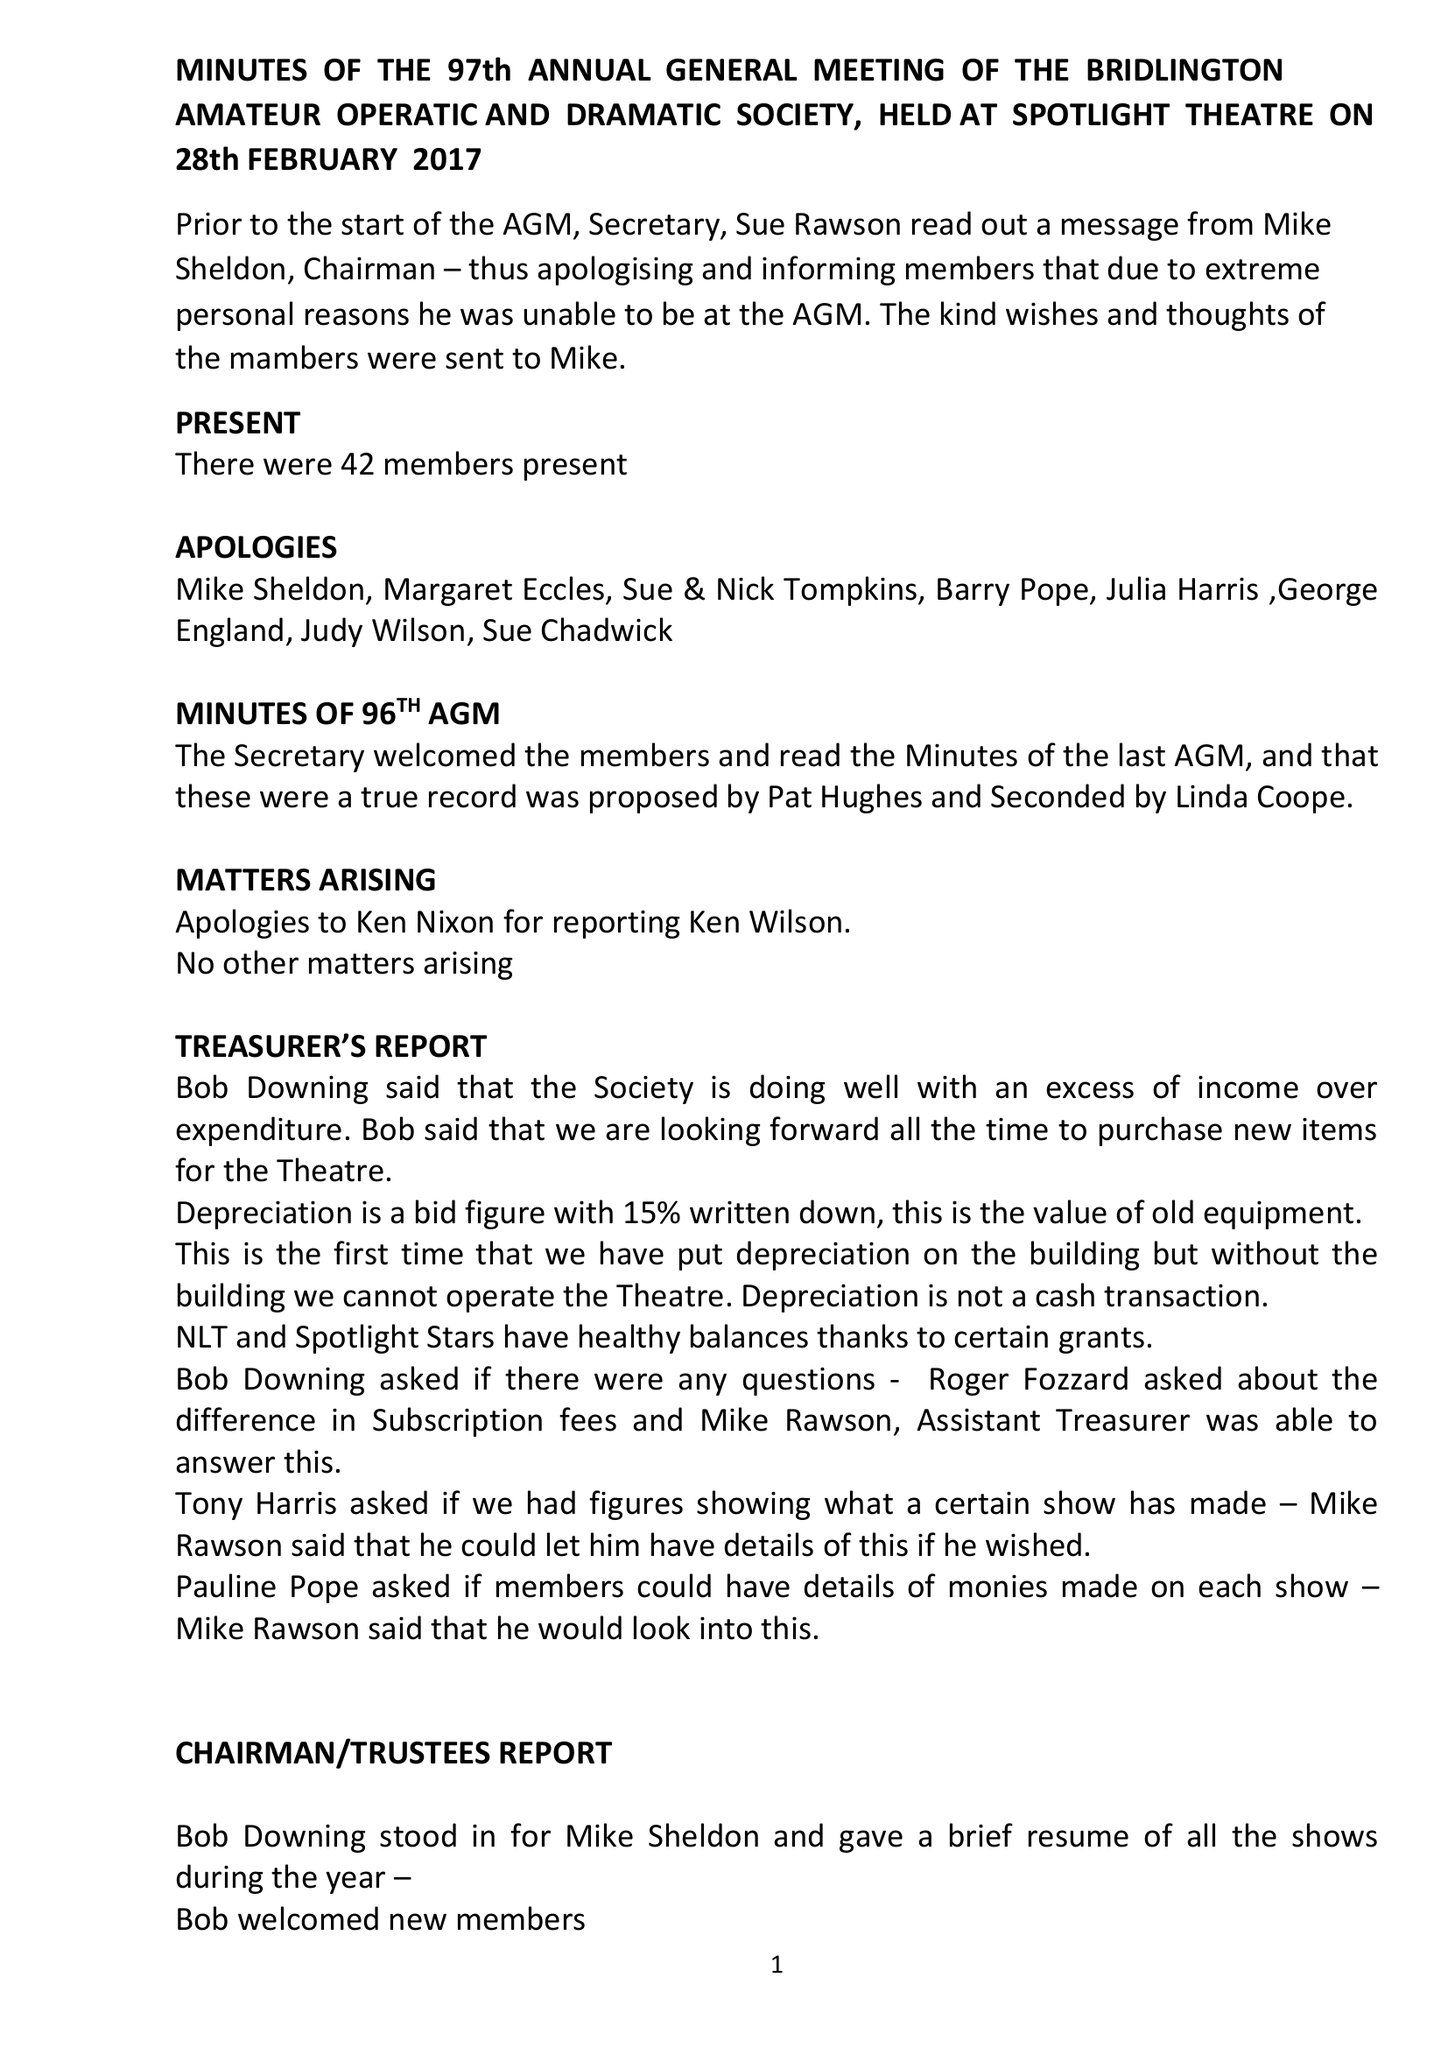What is the value for the address__post_town?
Answer the question using a single word or phrase. None 